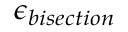Convert formula to latex. <formula><loc_0><loc_0><loc_500><loc_500>\epsilon _ { b i s e c t i o n }</formula> 